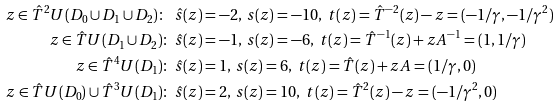<formula> <loc_0><loc_0><loc_500><loc_500>z \in \hat { T } ^ { 2 } U ( D _ { 0 } \cup D _ { 1 } \cup D _ { 2 } ) \colon \ & \hat { s } ( z ) = - 2 , \, s ( z ) = - 1 0 , \ t ( z ) = \hat { T } ^ { - 2 } ( z ) - z = ( - 1 / \gamma , - 1 / \gamma ^ { 2 } ) \\ z \in \hat { T } U ( D _ { 1 } \cup D _ { 2 } ) \colon \ & \hat { s } ( z ) = - 1 , \, s ( z ) = - 6 , \ t ( z ) = \hat { T } ^ { - 1 } ( z ) + z A ^ { - 1 } = ( 1 , 1 / \gamma ) \\ z \in \hat { T } ^ { 4 } U ( D _ { 1 } ) \colon \ & \hat { s } ( z ) = 1 , \, s ( z ) = 6 , \ t ( z ) = \hat { T } ( z ) + z A = ( 1 / \gamma , 0 ) \\ z \in \hat { T } U ( D _ { 0 } ) \cup \hat { T } ^ { 3 } U ( D _ { 1 } ) \colon \ & \hat { s } ( z ) = 2 , \, s ( z ) = 1 0 , \ t ( z ) = \hat { T } ^ { 2 } ( z ) - z = ( - 1 / \gamma ^ { 2 } , 0 )</formula> 